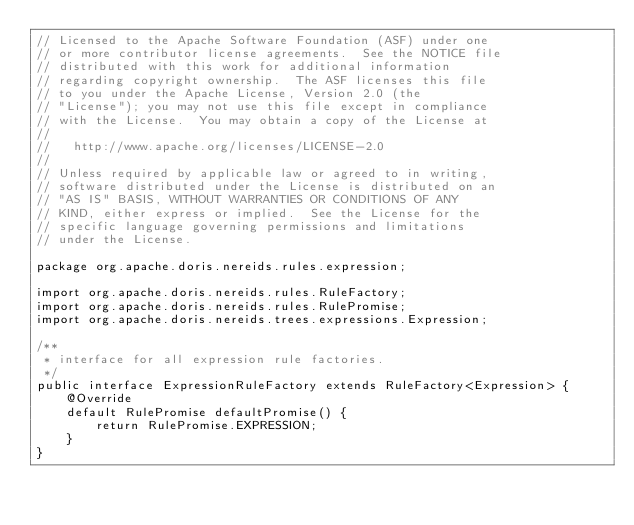<code> <loc_0><loc_0><loc_500><loc_500><_Java_>// Licensed to the Apache Software Foundation (ASF) under one
// or more contributor license agreements.  See the NOTICE file
// distributed with this work for additional information
// regarding copyright ownership.  The ASF licenses this file
// to you under the Apache License, Version 2.0 (the
// "License"); you may not use this file except in compliance
// with the License.  You may obtain a copy of the License at
//
//   http://www.apache.org/licenses/LICENSE-2.0
//
// Unless required by applicable law or agreed to in writing,
// software distributed under the License is distributed on an
// "AS IS" BASIS, WITHOUT WARRANTIES OR CONDITIONS OF ANY
// KIND, either express or implied.  See the License for the
// specific language governing permissions and limitations
// under the License.

package org.apache.doris.nereids.rules.expression;

import org.apache.doris.nereids.rules.RuleFactory;
import org.apache.doris.nereids.rules.RulePromise;
import org.apache.doris.nereids.trees.expressions.Expression;

/**
 * interface for all expression rule factories.
 */
public interface ExpressionRuleFactory extends RuleFactory<Expression> {
    @Override
    default RulePromise defaultPromise() {
        return RulePromise.EXPRESSION;
    }
}
</code> 